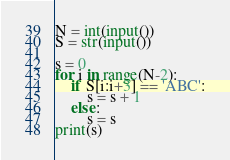<code> <loc_0><loc_0><loc_500><loc_500><_Python_>N = int(input())
S = str(input())

s = 0
for i in range(N-2):
    if S[i:i+3] == 'ABC':
        s = s + 1
    else:
        s = s
print(s)</code> 